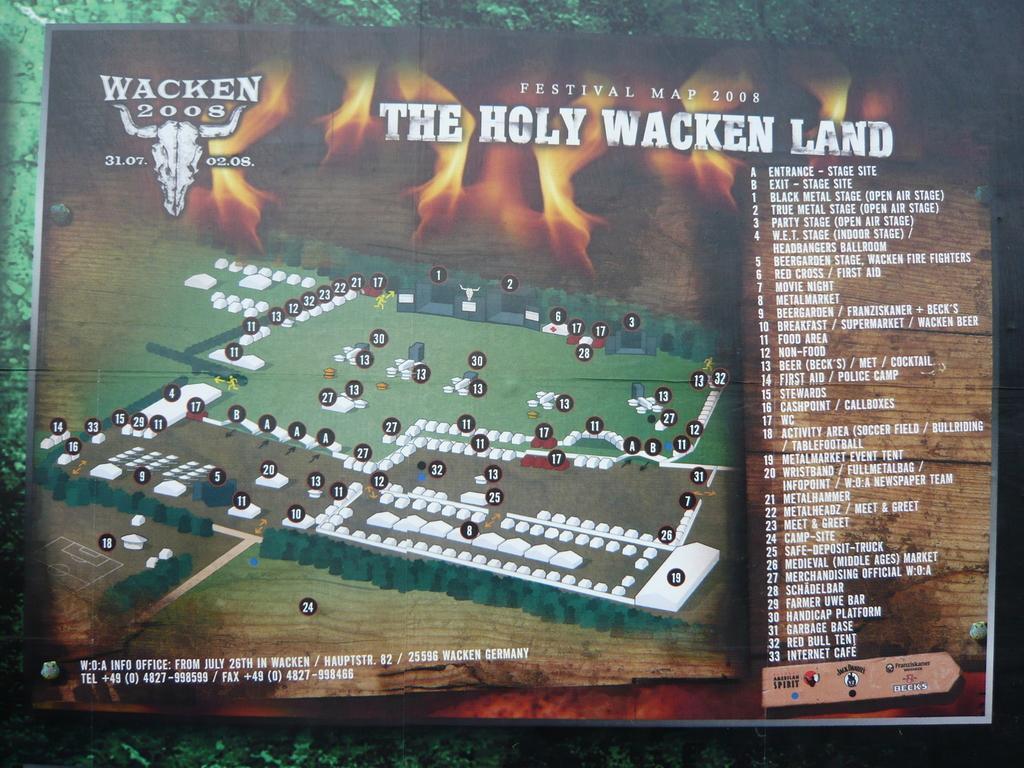Could you give a brief overview of what you see in this image? In this image I can see a board and on the left side of it I can see a map and on the other sides I can see something is written. 